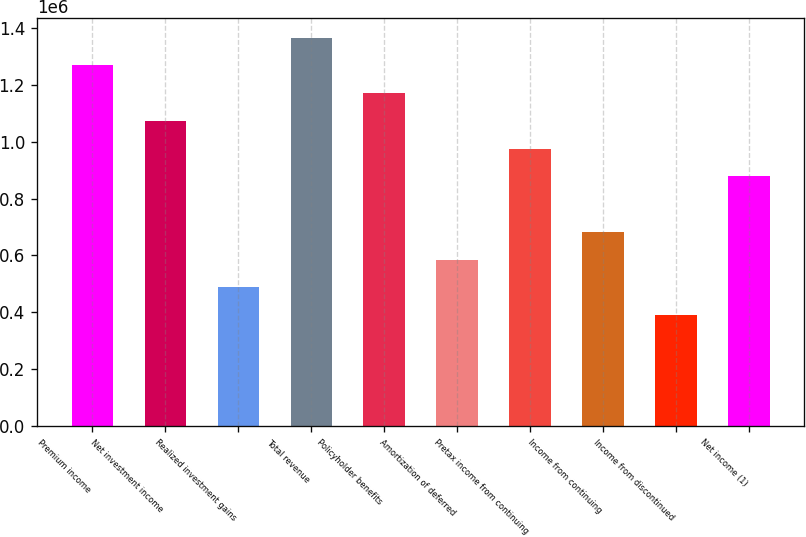<chart> <loc_0><loc_0><loc_500><loc_500><bar_chart><fcel>Premium income<fcel>Net investment income<fcel>Realized investment gains<fcel>Total revenue<fcel>Policyholder benefits<fcel>Amortization of deferred<fcel>Pretax income from continuing<fcel>Income from continuing<fcel>Income from discontinued<fcel>Net income (1)<nl><fcel>1.26795e+06<fcel>1.07288e+06<fcel>487673<fcel>1.36548e+06<fcel>1.17041e+06<fcel>585207<fcel>975345<fcel>682742<fcel>390138<fcel>877810<nl></chart> 